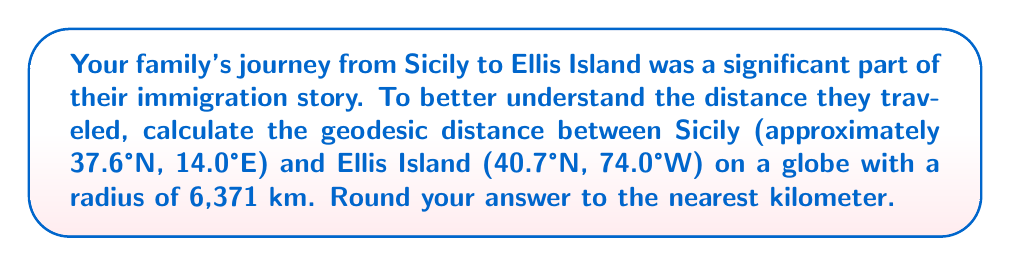Provide a solution to this math problem. To find the geodesic distance between two points on a sphere, we can use the great-circle distance formula:

$$d = R \cdot \arccos(\sin\phi_1 \sin\phi_2 + \cos\phi_1 \cos\phi_2 \cos(\lambda_2 - \lambda_1))$$

Where:
- $d$ is the distance
- $R$ is the radius of the Earth
- $\phi_1, \phi_2$ are the latitudes of the two points
- $\lambda_1, \lambda_2$ are the longitudes of the two points

Step 1: Convert the coordinates to radians:
Sicily: $\phi_1 = 37.6° \cdot \frac{\pi}{180} = 0.6563$ rad, $\lambda_1 = 14.0° \cdot \frac{\pi}{180} = 0.2443$ rad
Ellis Island: $\phi_2 = 40.7° \cdot \frac{\pi}{180} = 0.7101$ rad, $\lambda_2 = -74.0° \cdot \frac{\pi}{180} = -1.2915$ rad

Step 2: Calculate the difference in longitude:
$\lambda_2 - \lambda_1 = -1.2915 - 0.2443 = -1.5358$ rad

Step 3: Apply the formula:
$$\begin{align*}
d &= 6371 \cdot \arccos(\sin(0.6563) \sin(0.7101) + \cos(0.6563) \cos(0.7101) \cos(-1.5358)) \\
&= 6371 \cdot \arccos(0.6018 + 0.5944 \cdot 0.0161) \\
&= 6371 \cdot \arccos(0.6114) \\
&= 6371 \cdot 0.9125 \\
&= 5813.5 \text{ km}
\end{align*}$$

Step 4: Round to the nearest kilometer:
$5813.5 \text{ km} \approx 5814 \text{ km}$
Answer: 5814 km 